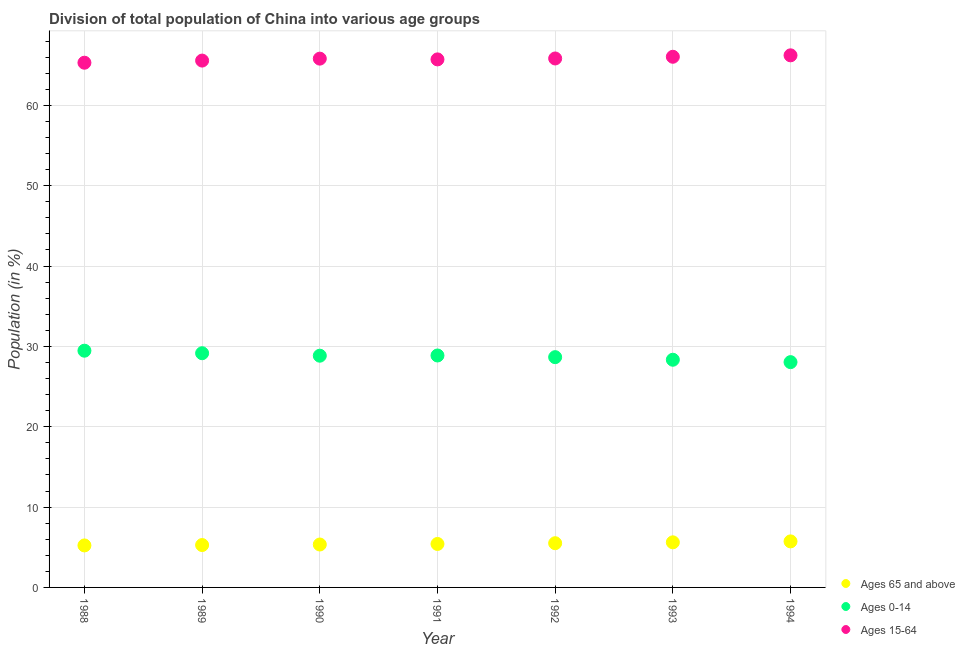How many different coloured dotlines are there?
Provide a short and direct response. 3. What is the percentage of population within the age-group 15-64 in 1990?
Make the answer very short. 65.82. Across all years, what is the maximum percentage of population within the age-group 0-14?
Provide a succinct answer. 29.46. Across all years, what is the minimum percentage of population within the age-group 15-64?
Offer a terse response. 65.31. What is the total percentage of population within the age-group of 65 and above in the graph?
Give a very brief answer. 38.1. What is the difference between the percentage of population within the age-group 0-14 in 1988 and that in 1990?
Your answer should be compact. 0.62. What is the difference between the percentage of population within the age-group 15-64 in 1993 and the percentage of population within the age-group 0-14 in 1992?
Your answer should be very brief. 37.39. What is the average percentage of population within the age-group 0-14 per year?
Make the answer very short. 28.77. In the year 1991, what is the difference between the percentage of population within the age-group 15-64 and percentage of population within the age-group 0-14?
Your answer should be compact. 36.85. In how many years, is the percentage of population within the age-group of 65 and above greater than 10 %?
Make the answer very short. 0. What is the ratio of the percentage of population within the age-group 0-14 in 1991 to that in 1993?
Provide a succinct answer. 1.02. Is the percentage of population within the age-group 15-64 in 1992 less than that in 1993?
Your response must be concise. Yes. Is the difference between the percentage of population within the age-group 15-64 in 1989 and 1990 greater than the difference between the percentage of population within the age-group of 65 and above in 1989 and 1990?
Offer a terse response. No. What is the difference between the highest and the second highest percentage of population within the age-group of 65 and above?
Make the answer very short. 0.12. What is the difference between the highest and the lowest percentage of population within the age-group 15-64?
Your response must be concise. 0.92. In how many years, is the percentage of population within the age-group of 65 and above greater than the average percentage of population within the age-group of 65 and above taken over all years?
Give a very brief answer. 3. Is it the case that in every year, the sum of the percentage of population within the age-group of 65 and above and percentage of population within the age-group 0-14 is greater than the percentage of population within the age-group 15-64?
Give a very brief answer. No. Is the percentage of population within the age-group 15-64 strictly greater than the percentage of population within the age-group of 65 and above over the years?
Your answer should be very brief. Yes. Is the percentage of population within the age-group 0-14 strictly less than the percentage of population within the age-group of 65 and above over the years?
Make the answer very short. No. How many years are there in the graph?
Provide a succinct answer. 7. What is the difference between two consecutive major ticks on the Y-axis?
Your response must be concise. 10. Are the values on the major ticks of Y-axis written in scientific E-notation?
Give a very brief answer. No. Does the graph contain any zero values?
Ensure brevity in your answer.  No. Does the graph contain grids?
Give a very brief answer. Yes. Where does the legend appear in the graph?
Your answer should be compact. Bottom right. What is the title of the graph?
Give a very brief answer. Division of total population of China into various age groups
. What is the label or title of the X-axis?
Your response must be concise. Year. What is the label or title of the Y-axis?
Make the answer very short. Population (in %). What is the Population (in %) in Ages 65 and above in 1988?
Offer a terse response. 5.23. What is the Population (in %) in Ages 0-14 in 1988?
Your response must be concise. 29.46. What is the Population (in %) of Ages 15-64 in 1988?
Keep it short and to the point. 65.31. What is the Population (in %) of Ages 65 and above in 1989?
Make the answer very short. 5.28. What is the Population (in %) in Ages 0-14 in 1989?
Provide a short and direct response. 29.15. What is the Population (in %) of Ages 15-64 in 1989?
Make the answer very short. 65.57. What is the Population (in %) in Ages 65 and above in 1990?
Your response must be concise. 5.34. What is the Population (in %) of Ages 0-14 in 1990?
Provide a succinct answer. 28.84. What is the Population (in %) of Ages 15-64 in 1990?
Your response must be concise. 65.82. What is the Population (in %) of Ages 65 and above in 1991?
Make the answer very short. 5.41. What is the Population (in %) in Ages 0-14 in 1991?
Your response must be concise. 28.87. What is the Population (in %) of Ages 15-64 in 1991?
Your response must be concise. 65.72. What is the Population (in %) of Ages 65 and above in 1992?
Your answer should be very brief. 5.5. What is the Population (in %) in Ages 0-14 in 1992?
Provide a succinct answer. 28.66. What is the Population (in %) in Ages 15-64 in 1992?
Make the answer very short. 65.84. What is the Population (in %) in Ages 65 and above in 1993?
Your answer should be compact. 5.61. What is the Population (in %) of Ages 0-14 in 1993?
Offer a terse response. 28.34. What is the Population (in %) of Ages 15-64 in 1993?
Give a very brief answer. 66.05. What is the Population (in %) in Ages 65 and above in 1994?
Your answer should be compact. 5.73. What is the Population (in %) in Ages 0-14 in 1994?
Offer a very short reply. 28.04. What is the Population (in %) of Ages 15-64 in 1994?
Ensure brevity in your answer.  66.23. Across all years, what is the maximum Population (in %) in Ages 65 and above?
Ensure brevity in your answer.  5.73. Across all years, what is the maximum Population (in %) in Ages 0-14?
Make the answer very short. 29.46. Across all years, what is the maximum Population (in %) of Ages 15-64?
Offer a terse response. 66.23. Across all years, what is the minimum Population (in %) in Ages 65 and above?
Your answer should be very brief. 5.23. Across all years, what is the minimum Population (in %) of Ages 0-14?
Your response must be concise. 28.04. Across all years, what is the minimum Population (in %) of Ages 15-64?
Give a very brief answer. 65.31. What is the total Population (in %) in Ages 65 and above in the graph?
Your response must be concise. 38.1. What is the total Population (in %) in Ages 0-14 in the graph?
Your answer should be compact. 201.36. What is the total Population (in %) of Ages 15-64 in the graph?
Ensure brevity in your answer.  460.53. What is the difference between the Population (in %) in Ages 65 and above in 1988 and that in 1989?
Offer a terse response. -0.05. What is the difference between the Population (in %) of Ages 0-14 in 1988 and that in 1989?
Offer a terse response. 0.32. What is the difference between the Population (in %) in Ages 15-64 in 1988 and that in 1989?
Ensure brevity in your answer.  -0.27. What is the difference between the Population (in %) of Ages 65 and above in 1988 and that in 1990?
Ensure brevity in your answer.  -0.11. What is the difference between the Population (in %) of Ages 0-14 in 1988 and that in 1990?
Keep it short and to the point. 0.62. What is the difference between the Population (in %) of Ages 15-64 in 1988 and that in 1990?
Ensure brevity in your answer.  -0.51. What is the difference between the Population (in %) of Ages 65 and above in 1988 and that in 1991?
Your response must be concise. -0.18. What is the difference between the Population (in %) in Ages 0-14 in 1988 and that in 1991?
Make the answer very short. 0.6. What is the difference between the Population (in %) of Ages 15-64 in 1988 and that in 1991?
Provide a succinct answer. -0.41. What is the difference between the Population (in %) in Ages 65 and above in 1988 and that in 1992?
Provide a succinct answer. -0.28. What is the difference between the Population (in %) of Ages 0-14 in 1988 and that in 1992?
Ensure brevity in your answer.  0.8. What is the difference between the Population (in %) of Ages 15-64 in 1988 and that in 1992?
Make the answer very short. -0.53. What is the difference between the Population (in %) in Ages 65 and above in 1988 and that in 1993?
Your answer should be compact. -0.39. What is the difference between the Population (in %) of Ages 0-14 in 1988 and that in 1993?
Ensure brevity in your answer.  1.13. What is the difference between the Population (in %) in Ages 15-64 in 1988 and that in 1993?
Give a very brief answer. -0.74. What is the difference between the Population (in %) in Ages 65 and above in 1988 and that in 1994?
Your answer should be very brief. -0.5. What is the difference between the Population (in %) in Ages 0-14 in 1988 and that in 1994?
Make the answer very short. 1.42. What is the difference between the Population (in %) in Ages 15-64 in 1988 and that in 1994?
Provide a succinct answer. -0.92. What is the difference between the Population (in %) of Ages 65 and above in 1989 and that in 1990?
Give a very brief answer. -0.07. What is the difference between the Population (in %) of Ages 0-14 in 1989 and that in 1990?
Provide a succinct answer. 0.31. What is the difference between the Population (in %) of Ages 15-64 in 1989 and that in 1990?
Provide a succinct answer. -0.24. What is the difference between the Population (in %) in Ages 65 and above in 1989 and that in 1991?
Offer a very short reply. -0.13. What is the difference between the Population (in %) of Ages 0-14 in 1989 and that in 1991?
Give a very brief answer. 0.28. What is the difference between the Population (in %) in Ages 15-64 in 1989 and that in 1991?
Provide a short and direct response. -0.15. What is the difference between the Population (in %) of Ages 65 and above in 1989 and that in 1992?
Offer a very short reply. -0.23. What is the difference between the Population (in %) in Ages 0-14 in 1989 and that in 1992?
Ensure brevity in your answer.  0.49. What is the difference between the Population (in %) of Ages 15-64 in 1989 and that in 1992?
Provide a succinct answer. -0.26. What is the difference between the Population (in %) in Ages 65 and above in 1989 and that in 1993?
Ensure brevity in your answer.  -0.34. What is the difference between the Population (in %) in Ages 0-14 in 1989 and that in 1993?
Offer a very short reply. 0.81. What is the difference between the Population (in %) in Ages 15-64 in 1989 and that in 1993?
Ensure brevity in your answer.  -0.47. What is the difference between the Population (in %) of Ages 65 and above in 1989 and that in 1994?
Give a very brief answer. -0.45. What is the difference between the Population (in %) in Ages 0-14 in 1989 and that in 1994?
Make the answer very short. 1.11. What is the difference between the Population (in %) in Ages 15-64 in 1989 and that in 1994?
Keep it short and to the point. -0.65. What is the difference between the Population (in %) of Ages 65 and above in 1990 and that in 1991?
Your answer should be very brief. -0.07. What is the difference between the Population (in %) in Ages 0-14 in 1990 and that in 1991?
Your answer should be very brief. -0.03. What is the difference between the Population (in %) of Ages 15-64 in 1990 and that in 1991?
Keep it short and to the point. 0.09. What is the difference between the Population (in %) of Ages 65 and above in 1990 and that in 1992?
Keep it short and to the point. -0.16. What is the difference between the Population (in %) of Ages 0-14 in 1990 and that in 1992?
Offer a terse response. 0.18. What is the difference between the Population (in %) of Ages 15-64 in 1990 and that in 1992?
Keep it short and to the point. -0.02. What is the difference between the Population (in %) of Ages 65 and above in 1990 and that in 1993?
Keep it short and to the point. -0.27. What is the difference between the Population (in %) of Ages 0-14 in 1990 and that in 1993?
Your answer should be compact. 0.5. What is the difference between the Population (in %) of Ages 15-64 in 1990 and that in 1993?
Offer a terse response. -0.23. What is the difference between the Population (in %) of Ages 65 and above in 1990 and that in 1994?
Your answer should be very brief. -0.39. What is the difference between the Population (in %) in Ages 0-14 in 1990 and that in 1994?
Ensure brevity in your answer.  0.8. What is the difference between the Population (in %) of Ages 15-64 in 1990 and that in 1994?
Provide a succinct answer. -0.41. What is the difference between the Population (in %) in Ages 65 and above in 1991 and that in 1992?
Provide a short and direct response. -0.09. What is the difference between the Population (in %) of Ages 0-14 in 1991 and that in 1992?
Provide a succinct answer. 0.21. What is the difference between the Population (in %) of Ages 15-64 in 1991 and that in 1992?
Your response must be concise. -0.11. What is the difference between the Population (in %) in Ages 65 and above in 1991 and that in 1993?
Ensure brevity in your answer.  -0.2. What is the difference between the Population (in %) in Ages 0-14 in 1991 and that in 1993?
Keep it short and to the point. 0.53. What is the difference between the Population (in %) of Ages 15-64 in 1991 and that in 1993?
Keep it short and to the point. -0.33. What is the difference between the Population (in %) of Ages 65 and above in 1991 and that in 1994?
Keep it short and to the point. -0.32. What is the difference between the Population (in %) of Ages 0-14 in 1991 and that in 1994?
Your answer should be compact. 0.83. What is the difference between the Population (in %) of Ages 15-64 in 1991 and that in 1994?
Keep it short and to the point. -0.51. What is the difference between the Population (in %) in Ages 65 and above in 1992 and that in 1993?
Your answer should be very brief. -0.11. What is the difference between the Population (in %) in Ages 0-14 in 1992 and that in 1993?
Your response must be concise. 0.32. What is the difference between the Population (in %) in Ages 15-64 in 1992 and that in 1993?
Your response must be concise. -0.21. What is the difference between the Population (in %) in Ages 65 and above in 1992 and that in 1994?
Your response must be concise. -0.23. What is the difference between the Population (in %) in Ages 0-14 in 1992 and that in 1994?
Your answer should be very brief. 0.62. What is the difference between the Population (in %) in Ages 15-64 in 1992 and that in 1994?
Give a very brief answer. -0.39. What is the difference between the Population (in %) of Ages 65 and above in 1993 and that in 1994?
Give a very brief answer. -0.12. What is the difference between the Population (in %) in Ages 0-14 in 1993 and that in 1994?
Offer a terse response. 0.3. What is the difference between the Population (in %) in Ages 15-64 in 1993 and that in 1994?
Your answer should be compact. -0.18. What is the difference between the Population (in %) in Ages 65 and above in 1988 and the Population (in %) in Ages 0-14 in 1989?
Your answer should be compact. -23.92. What is the difference between the Population (in %) of Ages 65 and above in 1988 and the Population (in %) of Ages 15-64 in 1989?
Give a very brief answer. -60.35. What is the difference between the Population (in %) in Ages 0-14 in 1988 and the Population (in %) in Ages 15-64 in 1989?
Give a very brief answer. -36.11. What is the difference between the Population (in %) of Ages 65 and above in 1988 and the Population (in %) of Ages 0-14 in 1990?
Give a very brief answer. -23.61. What is the difference between the Population (in %) in Ages 65 and above in 1988 and the Population (in %) in Ages 15-64 in 1990?
Your answer should be very brief. -60.59. What is the difference between the Population (in %) in Ages 0-14 in 1988 and the Population (in %) in Ages 15-64 in 1990?
Offer a very short reply. -36.35. What is the difference between the Population (in %) in Ages 65 and above in 1988 and the Population (in %) in Ages 0-14 in 1991?
Offer a terse response. -23.64. What is the difference between the Population (in %) of Ages 65 and above in 1988 and the Population (in %) of Ages 15-64 in 1991?
Keep it short and to the point. -60.5. What is the difference between the Population (in %) of Ages 0-14 in 1988 and the Population (in %) of Ages 15-64 in 1991?
Offer a very short reply. -36.26. What is the difference between the Population (in %) of Ages 65 and above in 1988 and the Population (in %) of Ages 0-14 in 1992?
Provide a short and direct response. -23.43. What is the difference between the Population (in %) in Ages 65 and above in 1988 and the Population (in %) in Ages 15-64 in 1992?
Give a very brief answer. -60.61. What is the difference between the Population (in %) of Ages 0-14 in 1988 and the Population (in %) of Ages 15-64 in 1992?
Make the answer very short. -36.37. What is the difference between the Population (in %) in Ages 65 and above in 1988 and the Population (in %) in Ages 0-14 in 1993?
Your answer should be compact. -23.11. What is the difference between the Population (in %) of Ages 65 and above in 1988 and the Population (in %) of Ages 15-64 in 1993?
Your response must be concise. -60.82. What is the difference between the Population (in %) of Ages 0-14 in 1988 and the Population (in %) of Ages 15-64 in 1993?
Offer a terse response. -36.58. What is the difference between the Population (in %) in Ages 65 and above in 1988 and the Population (in %) in Ages 0-14 in 1994?
Offer a very short reply. -22.81. What is the difference between the Population (in %) in Ages 65 and above in 1988 and the Population (in %) in Ages 15-64 in 1994?
Keep it short and to the point. -61. What is the difference between the Population (in %) in Ages 0-14 in 1988 and the Population (in %) in Ages 15-64 in 1994?
Offer a terse response. -36.76. What is the difference between the Population (in %) of Ages 65 and above in 1989 and the Population (in %) of Ages 0-14 in 1990?
Offer a terse response. -23.57. What is the difference between the Population (in %) of Ages 65 and above in 1989 and the Population (in %) of Ages 15-64 in 1990?
Your response must be concise. -60.54. What is the difference between the Population (in %) in Ages 0-14 in 1989 and the Population (in %) in Ages 15-64 in 1990?
Keep it short and to the point. -36.67. What is the difference between the Population (in %) of Ages 65 and above in 1989 and the Population (in %) of Ages 0-14 in 1991?
Provide a succinct answer. -23.59. What is the difference between the Population (in %) of Ages 65 and above in 1989 and the Population (in %) of Ages 15-64 in 1991?
Provide a short and direct response. -60.45. What is the difference between the Population (in %) in Ages 0-14 in 1989 and the Population (in %) in Ages 15-64 in 1991?
Offer a very short reply. -36.57. What is the difference between the Population (in %) in Ages 65 and above in 1989 and the Population (in %) in Ages 0-14 in 1992?
Your answer should be compact. -23.38. What is the difference between the Population (in %) of Ages 65 and above in 1989 and the Population (in %) of Ages 15-64 in 1992?
Your answer should be compact. -60.56. What is the difference between the Population (in %) in Ages 0-14 in 1989 and the Population (in %) in Ages 15-64 in 1992?
Offer a very short reply. -36.69. What is the difference between the Population (in %) of Ages 65 and above in 1989 and the Population (in %) of Ages 0-14 in 1993?
Make the answer very short. -23.06. What is the difference between the Population (in %) of Ages 65 and above in 1989 and the Population (in %) of Ages 15-64 in 1993?
Offer a very short reply. -60.77. What is the difference between the Population (in %) in Ages 0-14 in 1989 and the Population (in %) in Ages 15-64 in 1993?
Provide a succinct answer. -36.9. What is the difference between the Population (in %) in Ages 65 and above in 1989 and the Population (in %) in Ages 0-14 in 1994?
Make the answer very short. -22.77. What is the difference between the Population (in %) of Ages 65 and above in 1989 and the Population (in %) of Ages 15-64 in 1994?
Provide a succinct answer. -60.95. What is the difference between the Population (in %) of Ages 0-14 in 1989 and the Population (in %) of Ages 15-64 in 1994?
Ensure brevity in your answer.  -37.08. What is the difference between the Population (in %) in Ages 65 and above in 1990 and the Population (in %) in Ages 0-14 in 1991?
Offer a terse response. -23.53. What is the difference between the Population (in %) in Ages 65 and above in 1990 and the Population (in %) in Ages 15-64 in 1991?
Your response must be concise. -60.38. What is the difference between the Population (in %) of Ages 0-14 in 1990 and the Population (in %) of Ages 15-64 in 1991?
Your answer should be very brief. -36.88. What is the difference between the Population (in %) in Ages 65 and above in 1990 and the Population (in %) in Ages 0-14 in 1992?
Your response must be concise. -23.32. What is the difference between the Population (in %) of Ages 65 and above in 1990 and the Population (in %) of Ages 15-64 in 1992?
Ensure brevity in your answer.  -60.49. What is the difference between the Population (in %) in Ages 0-14 in 1990 and the Population (in %) in Ages 15-64 in 1992?
Give a very brief answer. -36.99. What is the difference between the Population (in %) of Ages 65 and above in 1990 and the Population (in %) of Ages 0-14 in 1993?
Give a very brief answer. -23. What is the difference between the Population (in %) of Ages 65 and above in 1990 and the Population (in %) of Ages 15-64 in 1993?
Give a very brief answer. -60.71. What is the difference between the Population (in %) in Ages 0-14 in 1990 and the Population (in %) in Ages 15-64 in 1993?
Keep it short and to the point. -37.21. What is the difference between the Population (in %) of Ages 65 and above in 1990 and the Population (in %) of Ages 0-14 in 1994?
Ensure brevity in your answer.  -22.7. What is the difference between the Population (in %) of Ages 65 and above in 1990 and the Population (in %) of Ages 15-64 in 1994?
Offer a terse response. -60.89. What is the difference between the Population (in %) in Ages 0-14 in 1990 and the Population (in %) in Ages 15-64 in 1994?
Provide a succinct answer. -37.39. What is the difference between the Population (in %) of Ages 65 and above in 1991 and the Population (in %) of Ages 0-14 in 1992?
Your response must be concise. -23.25. What is the difference between the Population (in %) of Ages 65 and above in 1991 and the Population (in %) of Ages 15-64 in 1992?
Offer a very short reply. -60.43. What is the difference between the Population (in %) of Ages 0-14 in 1991 and the Population (in %) of Ages 15-64 in 1992?
Offer a very short reply. -36.97. What is the difference between the Population (in %) in Ages 65 and above in 1991 and the Population (in %) in Ages 0-14 in 1993?
Provide a succinct answer. -22.93. What is the difference between the Population (in %) in Ages 65 and above in 1991 and the Population (in %) in Ages 15-64 in 1993?
Provide a succinct answer. -60.64. What is the difference between the Population (in %) in Ages 0-14 in 1991 and the Population (in %) in Ages 15-64 in 1993?
Provide a short and direct response. -37.18. What is the difference between the Population (in %) of Ages 65 and above in 1991 and the Population (in %) of Ages 0-14 in 1994?
Make the answer very short. -22.63. What is the difference between the Population (in %) of Ages 65 and above in 1991 and the Population (in %) of Ages 15-64 in 1994?
Give a very brief answer. -60.82. What is the difference between the Population (in %) of Ages 0-14 in 1991 and the Population (in %) of Ages 15-64 in 1994?
Provide a succinct answer. -37.36. What is the difference between the Population (in %) in Ages 65 and above in 1992 and the Population (in %) in Ages 0-14 in 1993?
Your answer should be very brief. -22.84. What is the difference between the Population (in %) of Ages 65 and above in 1992 and the Population (in %) of Ages 15-64 in 1993?
Offer a very short reply. -60.55. What is the difference between the Population (in %) of Ages 0-14 in 1992 and the Population (in %) of Ages 15-64 in 1993?
Ensure brevity in your answer.  -37.39. What is the difference between the Population (in %) of Ages 65 and above in 1992 and the Population (in %) of Ages 0-14 in 1994?
Provide a succinct answer. -22.54. What is the difference between the Population (in %) in Ages 65 and above in 1992 and the Population (in %) in Ages 15-64 in 1994?
Your response must be concise. -60.73. What is the difference between the Population (in %) of Ages 0-14 in 1992 and the Population (in %) of Ages 15-64 in 1994?
Offer a terse response. -37.57. What is the difference between the Population (in %) in Ages 65 and above in 1993 and the Population (in %) in Ages 0-14 in 1994?
Offer a terse response. -22.43. What is the difference between the Population (in %) in Ages 65 and above in 1993 and the Population (in %) in Ages 15-64 in 1994?
Your response must be concise. -60.61. What is the difference between the Population (in %) of Ages 0-14 in 1993 and the Population (in %) of Ages 15-64 in 1994?
Give a very brief answer. -37.89. What is the average Population (in %) in Ages 65 and above per year?
Your response must be concise. 5.44. What is the average Population (in %) of Ages 0-14 per year?
Your answer should be very brief. 28.77. What is the average Population (in %) of Ages 15-64 per year?
Give a very brief answer. 65.79. In the year 1988, what is the difference between the Population (in %) in Ages 65 and above and Population (in %) in Ages 0-14?
Ensure brevity in your answer.  -24.24. In the year 1988, what is the difference between the Population (in %) in Ages 65 and above and Population (in %) in Ages 15-64?
Your response must be concise. -60.08. In the year 1988, what is the difference between the Population (in %) in Ages 0-14 and Population (in %) in Ages 15-64?
Offer a terse response. -35.84. In the year 1989, what is the difference between the Population (in %) of Ages 65 and above and Population (in %) of Ages 0-14?
Offer a very short reply. -23.87. In the year 1989, what is the difference between the Population (in %) in Ages 65 and above and Population (in %) in Ages 15-64?
Your answer should be very brief. -60.3. In the year 1989, what is the difference between the Population (in %) in Ages 0-14 and Population (in %) in Ages 15-64?
Ensure brevity in your answer.  -36.42. In the year 1990, what is the difference between the Population (in %) of Ages 65 and above and Population (in %) of Ages 0-14?
Make the answer very short. -23.5. In the year 1990, what is the difference between the Population (in %) of Ages 65 and above and Population (in %) of Ages 15-64?
Keep it short and to the point. -60.47. In the year 1990, what is the difference between the Population (in %) in Ages 0-14 and Population (in %) in Ages 15-64?
Offer a very short reply. -36.97. In the year 1991, what is the difference between the Population (in %) of Ages 65 and above and Population (in %) of Ages 0-14?
Your answer should be compact. -23.46. In the year 1991, what is the difference between the Population (in %) of Ages 65 and above and Population (in %) of Ages 15-64?
Keep it short and to the point. -60.31. In the year 1991, what is the difference between the Population (in %) in Ages 0-14 and Population (in %) in Ages 15-64?
Your answer should be compact. -36.85. In the year 1992, what is the difference between the Population (in %) in Ages 65 and above and Population (in %) in Ages 0-14?
Make the answer very short. -23.16. In the year 1992, what is the difference between the Population (in %) of Ages 65 and above and Population (in %) of Ages 15-64?
Make the answer very short. -60.33. In the year 1992, what is the difference between the Population (in %) of Ages 0-14 and Population (in %) of Ages 15-64?
Offer a terse response. -37.18. In the year 1993, what is the difference between the Population (in %) in Ages 65 and above and Population (in %) in Ages 0-14?
Provide a short and direct response. -22.73. In the year 1993, what is the difference between the Population (in %) in Ages 65 and above and Population (in %) in Ages 15-64?
Your answer should be compact. -60.43. In the year 1993, what is the difference between the Population (in %) of Ages 0-14 and Population (in %) of Ages 15-64?
Give a very brief answer. -37.71. In the year 1994, what is the difference between the Population (in %) of Ages 65 and above and Population (in %) of Ages 0-14?
Provide a succinct answer. -22.31. In the year 1994, what is the difference between the Population (in %) in Ages 65 and above and Population (in %) in Ages 15-64?
Your answer should be compact. -60.5. In the year 1994, what is the difference between the Population (in %) of Ages 0-14 and Population (in %) of Ages 15-64?
Your response must be concise. -38.19. What is the ratio of the Population (in %) of Ages 0-14 in 1988 to that in 1989?
Your answer should be very brief. 1.01. What is the ratio of the Population (in %) of Ages 15-64 in 1988 to that in 1989?
Your answer should be compact. 1. What is the ratio of the Population (in %) of Ages 65 and above in 1988 to that in 1990?
Offer a very short reply. 0.98. What is the ratio of the Population (in %) in Ages 0-14 in 1988 to that in 1990?
Your response must be concise. 1.02. What is the ratio of the Population (in %) of Ages 65 and above in 1988 to that in 1991?
Your answer should be very brief. 0.97. What is the ratio of the Population (in %) in Ages 0-14 in 1988 to that in 1991?
Keep it short and to the point. 1.02. What is the ratio of the Population (in %) of Ages 15-64 in 1988 to that in 1991?
Ensure brevity in your answer.  0.99. What is the ratio of the Population (in %) of Ages 65 and above in 1988 to that in 1992?
Your answer should be very brief. 0.95. What is the ratio of the Population (in %) of Ages 0-14 in 1988 to that in 1992?
Give a very brief answer. 1.03. What is the ratio of the Population (in %) in Ages 15-64 in 1988 to that in 1992?
Offer a terse response. 0.99. What is the ratio of the Population (in %) of Ages 65 and above in 1988 to that in 1993?
Your response must be concise. 0.93. What is the ratio of the Population (in %) in Ages 0-14 in 1988 to that in 1993?
Offer a terse response. 1.04. What is the ratio of the Population (in %) of Ages 65 and above in 1988 to that in 1994?
Your answer should be very brief. 0.91. What is the ratio of the Population (in %) in Ages 0-14 in 1988 to that in 1994?
Ensure brevity in your answer.  1.05. What is the ratio of the Population (in %) of Ages 15-64 in 1988 to that in 1994?
Provide a short and direct response. 0.99. What is the ratio of the Population (in %) of Ages 65 and above in 1989 to that in 1990?
Your response must be concise. 0.99. What is the ratio of the Population (in %) in Ages 0-14 in 1989 to that in 1990?
Ensure brevity in your answer.  1.01. What is the ratio of the Population (in %) in Ages 15-64 in 1989 to that in 1990?
Offer a very short reply. 1. What is the ratio of the Population (in %) of Ages 65 and above in 1989 to that in 1991?
Offer a very short reply. 0.98. What is the ratio of the Population (in %) in Ages 0-14 in 1989 to that in 1991?
Provide a short and direct response. 1.01. What is the ratio of the Population (in %) in Ages 65 and above in 1989 to that in 1992?
Provide a succinct answer. 0.96. What is the ratio of the Population (in %) in Ages 0-14 in 1989 to that in 1992?
Your answer should be compact. 1.02. What is the ratio of the Population (in %) in Ages 15-64 in 1989 to that in 1992?
Offer a very short reply. 1. What is the ratio of the Population (in %) of Ages 65 and above in 1989 to that in 1993?
Ensure brevity in your answer.  0.94. What is the ratio of the Population (in %) in Ages 0-14 in 1989 to that in 1993?
Provide a succinct answer. 1.03. What is the ratio of the Population (in %) of Ages 15-64 in 1989 to that in 1993?
Ensure brevity in your answer.  0.99. What is the ratio of the Population (in %) of Ages 65 and above in 1989 to that in 1994?
Make the answer very short. 0.92. What is the ratio of the Population (in %) of Ages 0-14 in 1989 to that in 1994?
Your response must be concise. 1.04. What is the ratio of the Population (in %) in Ages 65 and above in 1990 to that in 1991?
Keep it short and to the point. 0.99. What is the ratio of the Population (in %) in Ages 65 and above in 1990 to that in 1992?
Provide a short and direct response. 0.97. What is the ratio of the Population (in %) in Ages 0-14 in 1990 to that in 1992?
Give a very brief answer. 1.01. What is the ratio of the Population (in %) of Ages 15-64 in 1990 to that in 1992?
Make the answer very short. 1. What is the ratio of the Population (in %) of Ages 65 and above in 1990 to that in 1993?
Offer a terse response. 0.95. What is the ratio of the Population (in %) of Ages 0-14 in 1990 to that in 1993?
Provide a succinct answer. 1.02. What is the ratio of the Population (in %) in Ages 65 and above in 1990 to that in 1994?
Keep it short and to the point. 0.93. What is the ratio of the Population (in %) of Ages 0-14 in 1990 to that in 1994?
Your answer should be very brief. 1.03. What is the ratio of the Population (in %) of Ages 15-64 in 1990 to that in 1994?
Your answer should be very brief. 0.99. What is the ratio of the Population (in %) in Ages 65 and above in 1991 to that in 1992?
Offer a terse response. 0.98. What is the ratio of the Population (in %) of Ages 15-64 in 1991 to that in 1992?
Ensure brevity in your answer.  1. What is the ratio of the Population (in %) of Ages 65 and above in 1991 to that in 1993?
Your answer should be very brief. 0.96. What is the ratio of the Population (in %) in Ages 0-14 in 1991 to that in 1993?
Provide a succinct answer. 1.02. What is the ratio of the Population (in %) in Ages 65 and above in 1991 to that in 1994?
Keep it short and to the point. 0.94. What is the ratio of the Population (in %) of Ages 0-14 in 1991 to that in 1994?
Your answer should be very brief. 1.03. What is the ratio of the Population (in %) of Ages 65 and above in 1992 to that in 1993?
Provide a short and direct response. 0.98. What is the ratio of the Population (in %) of Ages 0-14 in 1992 to that in 1993?
Give a very brief answer. 1.01. What is the ratio of the Population (in %) of Ages 65 and above in 1992 to that in 1994?
Provide a short and direct response. 0.96. What is the ratio of the Population (in %) of Ages 0-14 in 1992 to that in 1994?
Your answer should be very brief. 1.02. What is the ratio of the Population (in %) in Ages 15-64 in 1992 to that in 1994?
Ensure brevity in your answer.  0.99. What is the ratio of the Population (in %) of Ages 65 and above in 1993 to that in 1994?
Make the answer very short. 0.98. What is the ratio of the Population (in %) of Ages 0-14 in 1993 to that in 1994?
Provide a succinct answer. 1.01. What is the difference between the highest and the second highest Population (in %) in Ages 65 and above?
Provide a succinct answer. 0.12. What is the difference between the highest and the second highest Population (in %) of Ages 0-14?
Provide a succinct answer. 0.32. What is the difference between the highest and the second highest Population (in %) in Ages 15-64?
Make the answer very short. 0.18. What is the difference between the highest and the lowest Population (in %) of Ages 65 and above?
Ensure brevity in your answer.  0.5. What is the difference between the highest and the lowest Population (in %) in Ages 0-14?
Your answer should be very brief. 1.42. What is the difference between the highest and the lowest Population (in %) of Ages 15-64?
Offer a terse response. 0.92. 